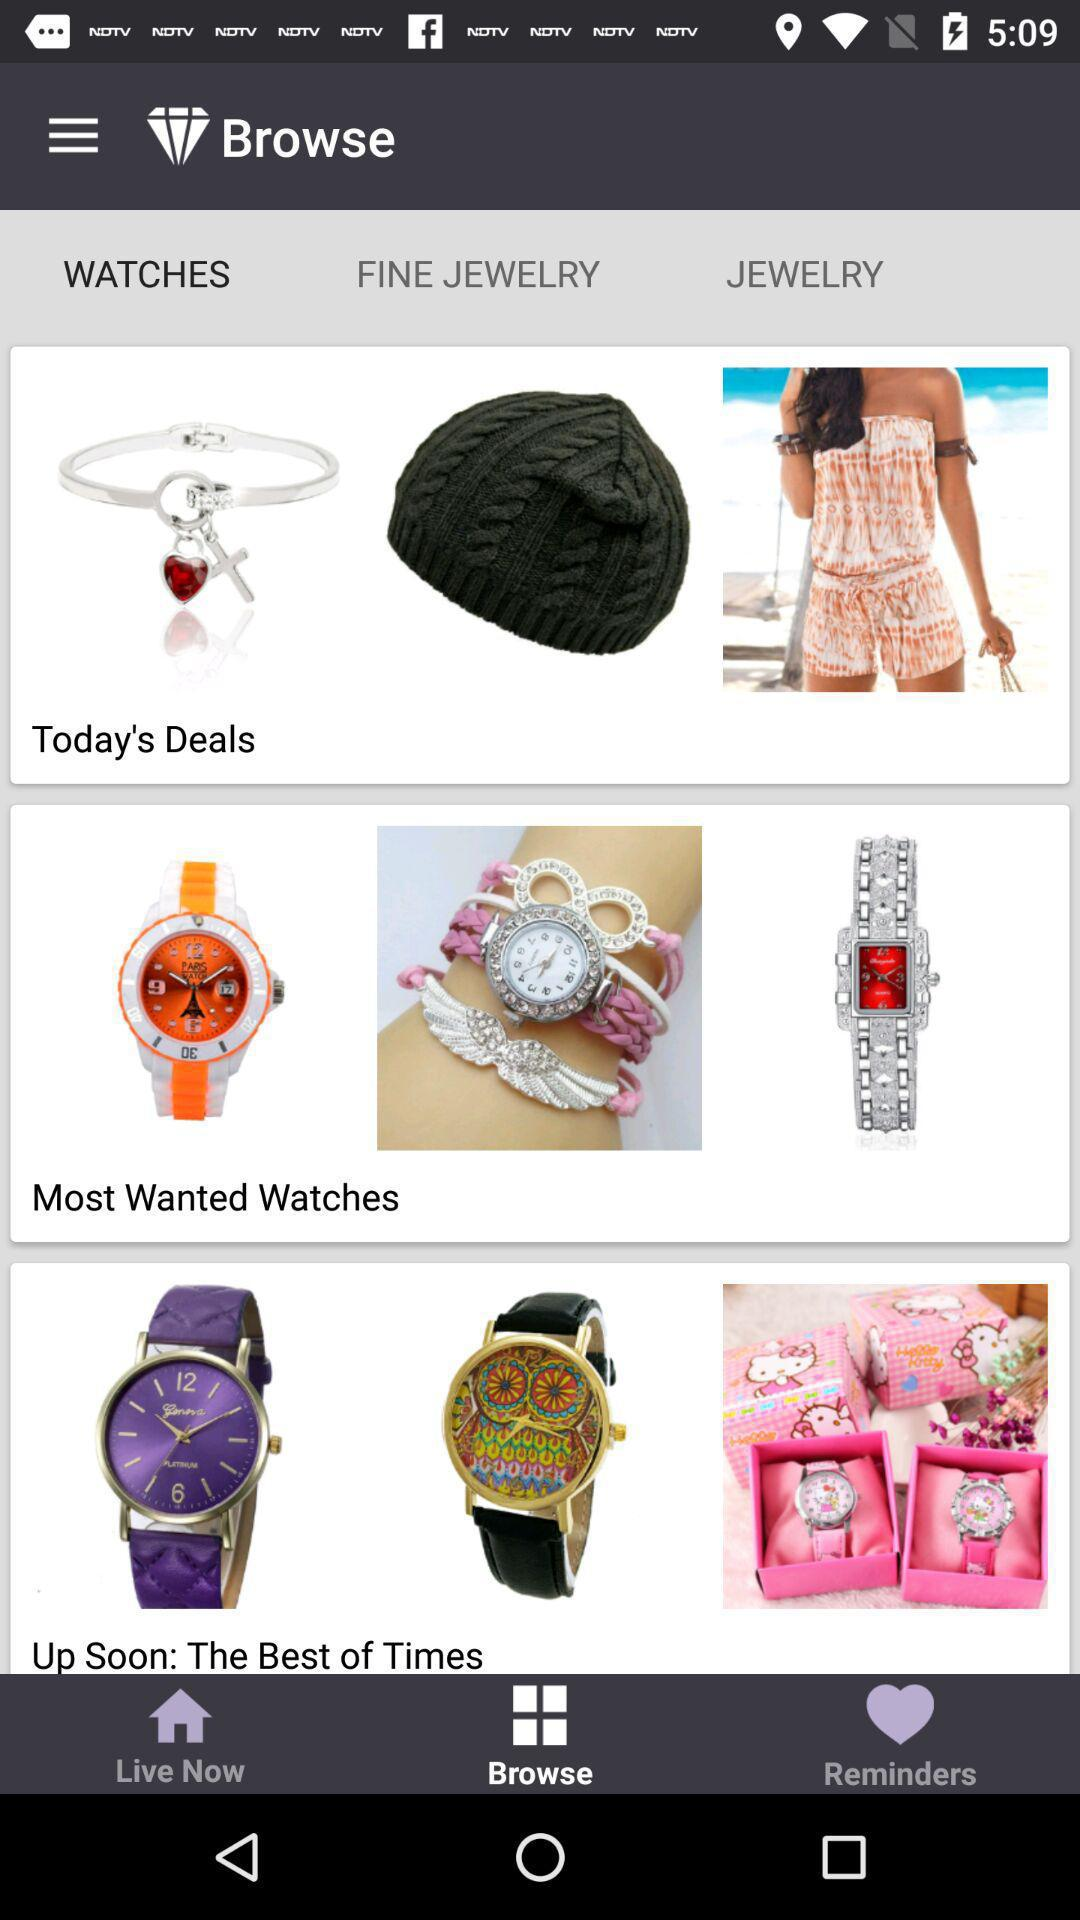Which tab is selected? The selected tab is "Browse". 